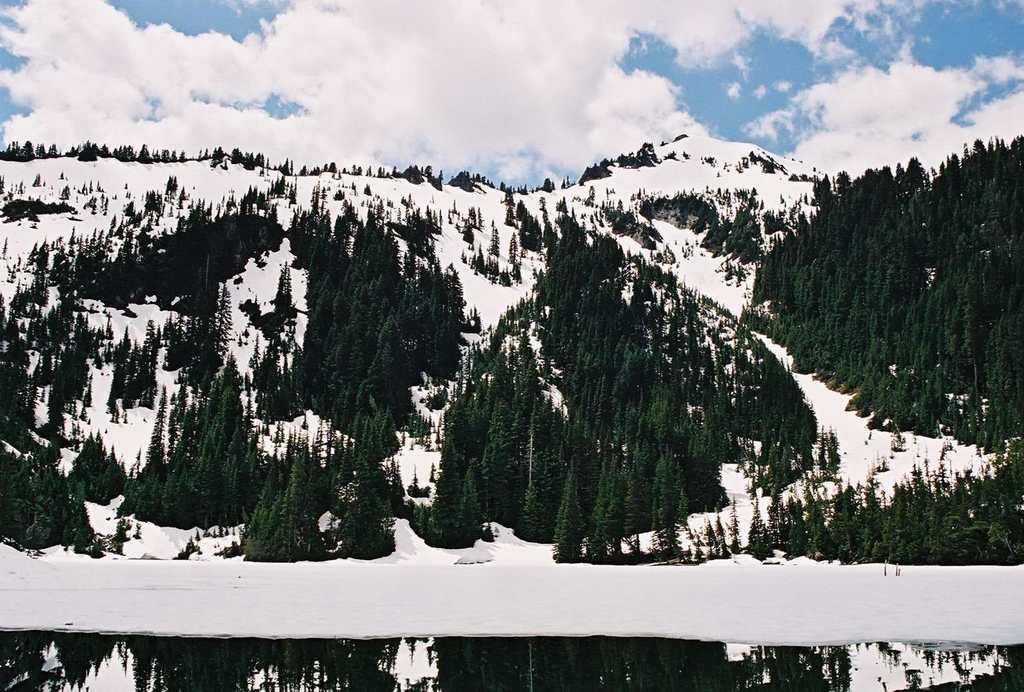Describe this image in one or two sentences. In this image we can see a group of trees, the ice hills and the sky which looks cloudy. On the bottom of the image we can see some water. 